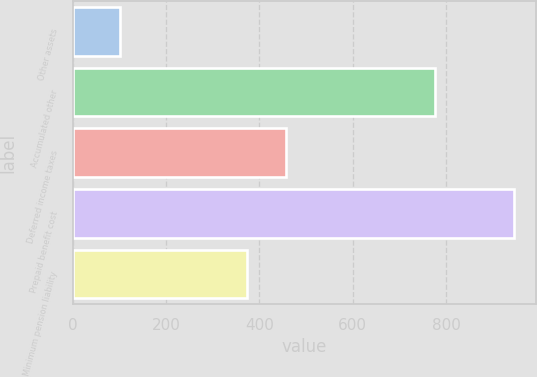Convert chart. <chart><loc_0><loc_0><loc_500><loc_500><bar_chart><fcel>Other assets<fcel>Accumulated other<fcel>Deferred income taxes<fcel>Prepaid benefit cost<fcel>Minimum pension liability<nl><fcel>101<fcel>775<fcel>457.4<fcel>945<fcel>373<nl></chart> 